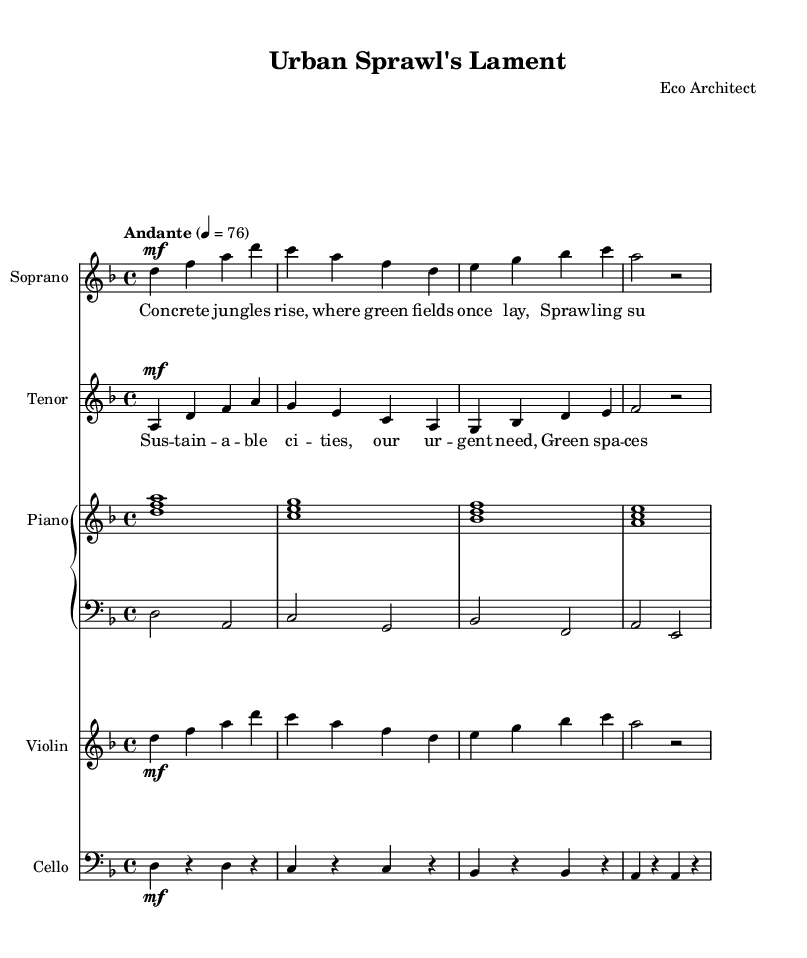What is the key signature of this music? The key signature is D minor, which has one flat. This can be identified by looking at the key signature notation at the beginning of the score.
Answer: D minor What is the time signature of the music? The time signature is 4/4, which indicates that there are four beats in each measure, and the quarter note gets one beat. This is indicated at the beginning of the score.
Answer: 4/4 What is the tempo marking of this music? The tempo marking is Andante, which means a moderate tempo. This is noted in the score where it describes the intended speed of the music.
Answer: Andante How many measures are in the soprano line? The soprano line contains four measures. This can be counted by observing the grouping of notes and bar lines in the staff.
Answer: Four What is the dynamic marking for the tenor part? The dynamic marking for the tenor part is mf, which means 'mezzo forte' or moderately loud. This is indicated directly above the notes in the tenor staff.
Answer: mf How does the first verse relate to the structure of the opera? The first verse addresses urban issues, reflecting on how urban development impacts the environment, which ties directly into the opera's theme of sustainable cities. This relationship is evidenced by the content of the lyrics and their thematic depth within the context of the entire piece.
Answer: Social issues What instrument plays the harmony in this score? The harmony is played by the Piano. This can be recognized by seeing the designated Piano staff that includes both the right and left-hand parts.
Answer: Piano 